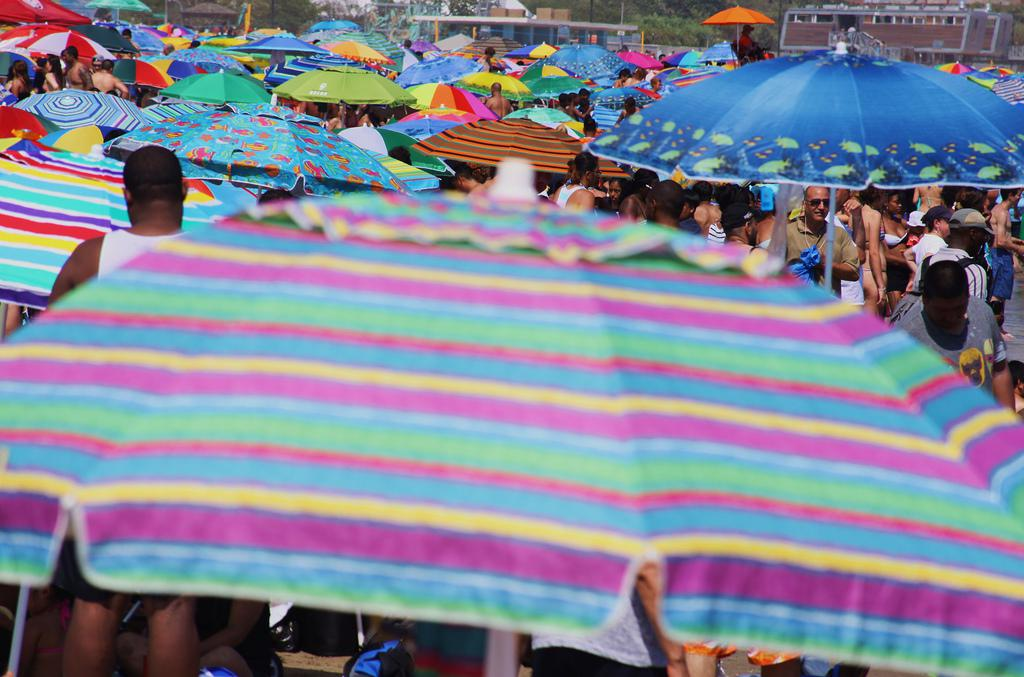Question: who are these people?
Choices:
A. Tribal.
B. Foreigners.
C. Citizens.
D. Japanese.
Answer with the letter. Answer: C Question: what are these colorful objects?
Choices:
A. Balls.
B. Papers.
C. Umbrellas.
D. Books.
Answer with the letter. Answer: C Question: what color are the stripes?
Choices:
A. White.
B. Purple blue and yellow.
C. Black.
D. Orange.
Answer with the letter. Answer: B Question: what is colorful?
Choices:
A. The car.
B. The clothes.
C. The umbrellas.
D. The paintingd.
Answer with the letter. Answer: C Question: how are these people doing?
Choices:
A. Sad.
B. Okay.
C. Excited.
D. Good.
Answer with the letter. Answer: D Question: what sticks out from the umbrella?
Choices:
A. A man's head.
B. A woman's hand.
C. A child's foot.
D. A woman's purse.
Answer with the letter. Answer: A Question: what kind of blue is the umbrella?
Choices:
A. Navy.
B. Turquoise.
C. Teal.
D. Cobalt.
Answer with the letter. Answer: D Question: who doesn't have an umbrella?
Choices:
A. One of the women.
B. The small girl in front.
C. The people on the left side.
D. One of the men.
Answer with the letter. Answer: D Question: why are the umbrellas up?
Choices:
A. It is raining.
B. There is a parade and confetti is flying.
C. It must be for shade.
D. There are storms in the forecast.
Answer with the letter. Answer: C Question: what is colorful in the picture?
Choices:
A. Many beautiful hats.
B. Many umbrellas.
C. The women's dresses.
D. The shining faces of the people.
Answer with the letter. Answer: B Question: what color umbrella is in the back left?
Choices:
A. A black and white polka dot umbrella.
B. A red and white striped umbrella.
C. A yellow umbrella.
D. A blue and green striped umbrella.
Answer with the letter. Answer: B 